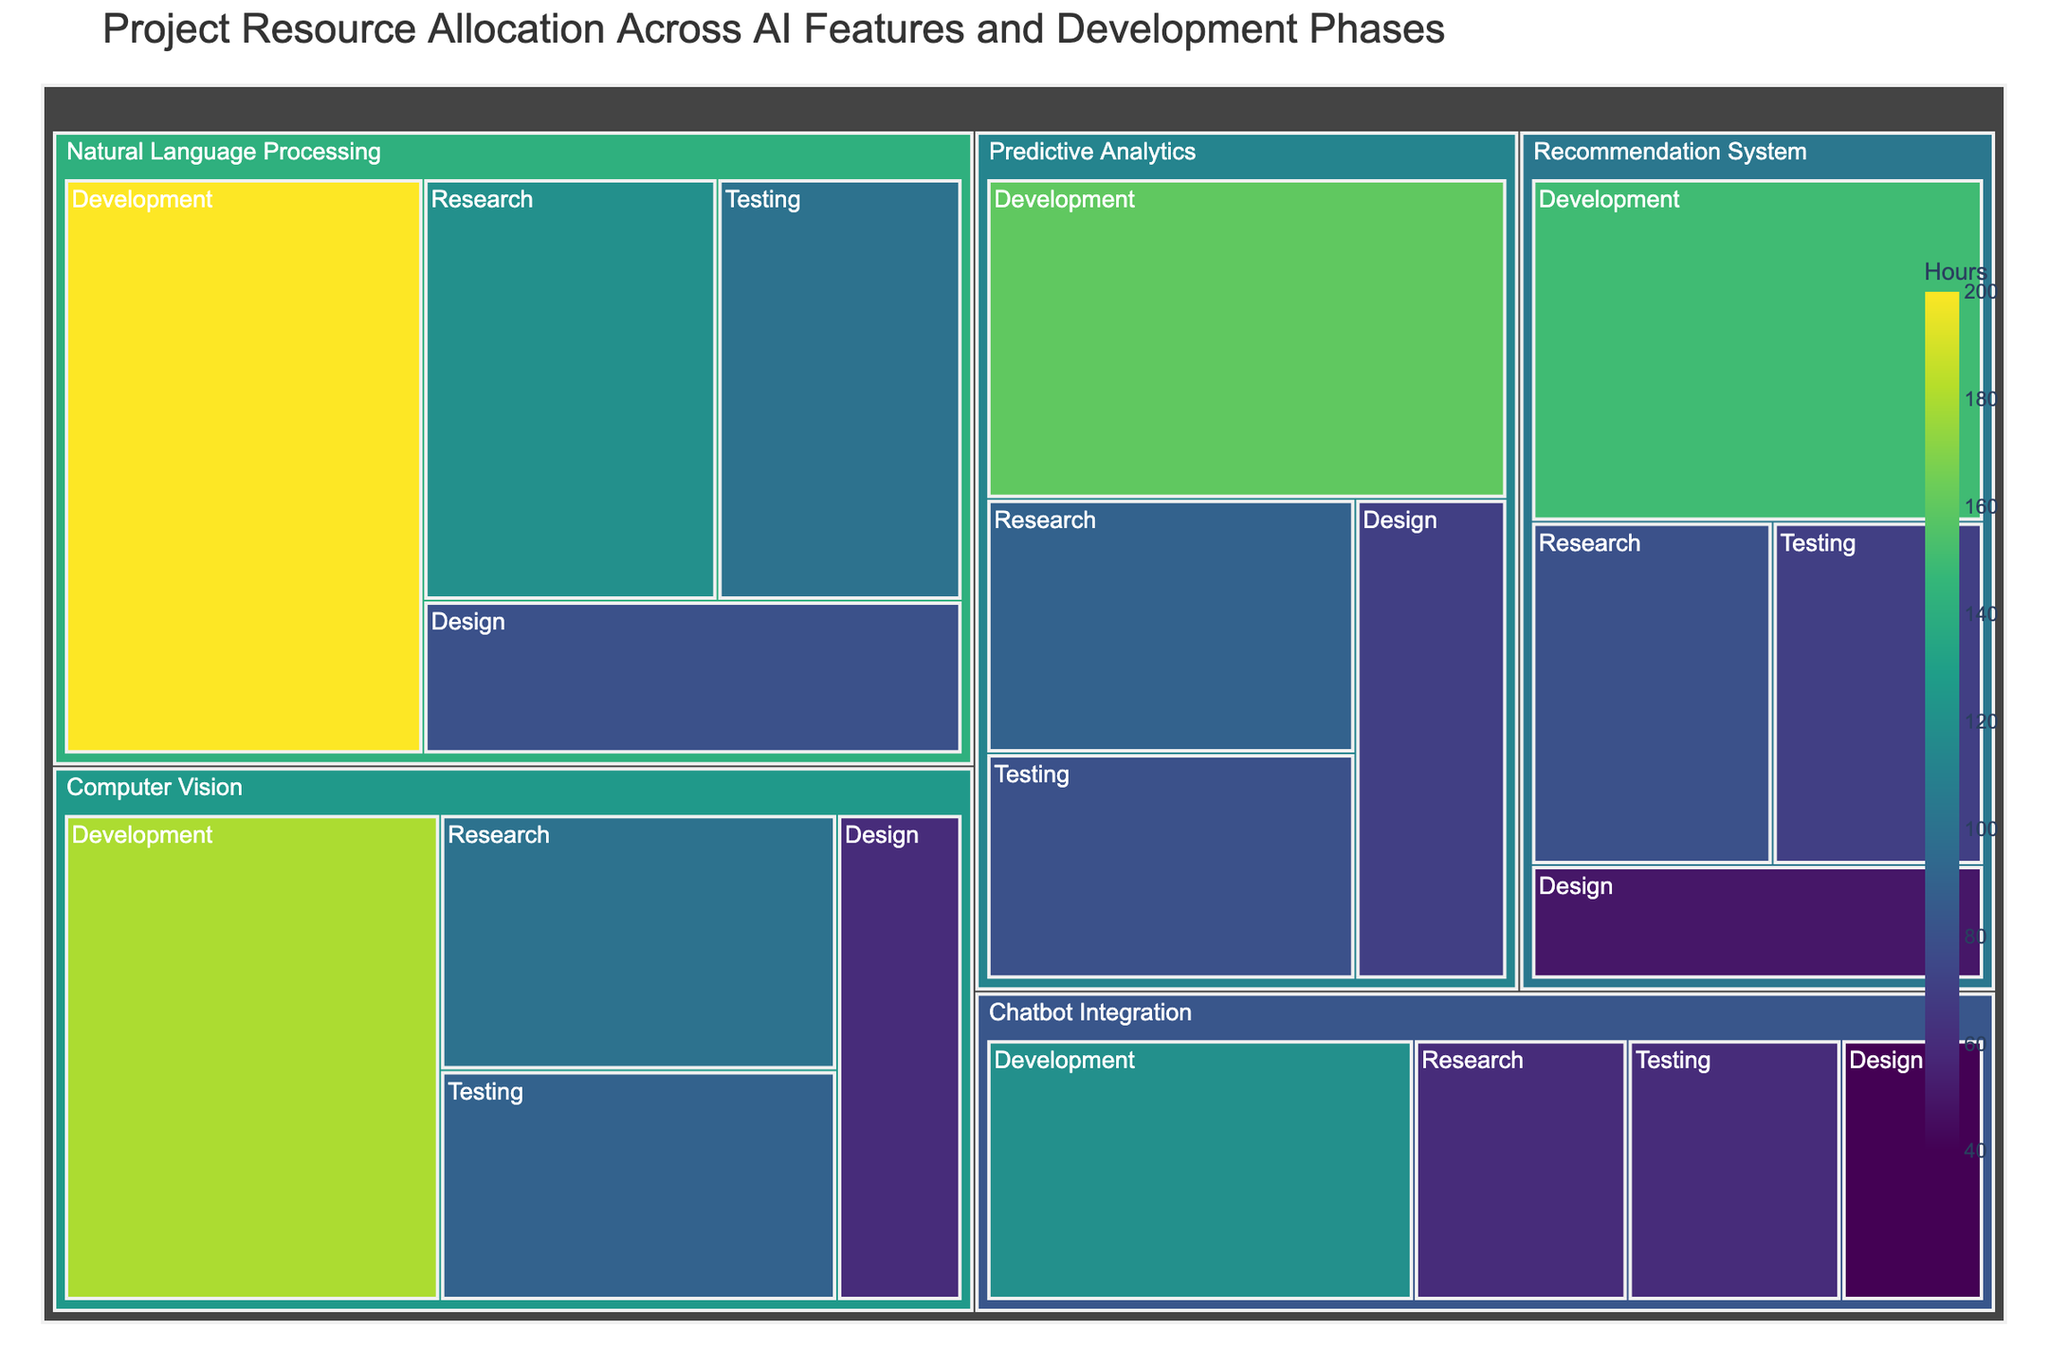What is the total number of hours allocated to the 'Computer Vision' feature? To find the total number of hours allocated to 'Computer Vision', add up the hours for all phases under this feature: Research (100), Design (60), Development (180), and Testing (90). So, 100 + 60 + 180 + 90 = 430 hours.
Answer: 430 Which phase has the highest resource allocation within the 'Natural Language Processing' feature? For 'Natural Language Processing', compare the hours across phases: Research (120), Design (80), Development (200), and Testing (100). The Development phase has the highest allocation with 200 hours.
Answer: Development How many more hours are allocated to 'Predictive Analytics' Development compared to 'Chatbot Integration' Development? Subtract the hours in 'Chatbot Integration' Development (120) from 'Predictive Analytics' Development (160). So, 160 - 120 = 40 hours.
Answer: 40 Which AI feature has the least amount of hours allocated to the Research phase? Compare the Research phase hours across all features: Natural Language Processing (120), Computer Vision (100), Recommendation System (80), Chatbot Integration (60), and Predictive Analytics (90). Chatbot Integration has the least with 60 hours.
Answer: Chatbot Integration What is the total number of hours allocated across all features and phases in the project? Sum all the hours allocated: 120 + 80 + 200 + 100 + 100 + 60 + 180 + 90 + 80 + 50 + 150 + 70 + 60 + 40 + 120 + 60 + 90 + 70 + 160 + 80. The total is 1830 hours.
Answer: 1830 Which phase has the highest overall resource allocation across all features? Sum the hours for each phase across all features: Research (450), Design (300), Development (810), and Testing (400). Development has the highest allocation with 810 hours.
Answer: Development What is the average number of hours allocated to the Testing phase for all features? To find the average, sum the hours for the Testing phase across all features (100 + 90 + 70 + 60 + 80) which equals 400, and then divide by the number of features (5). So, 400 / 5 = 80 hours.
Answer: 80 How does the resource allocation for 'Recommendation System' Development compare to the Design phase of 'Natural Language Processing'? The Development phase of 'Recommendation System' has 150 hours, and the Design phase of 'Natural Language Processing' has 80 hours. 150 is greater than 80.
Answer: Greater Which phase has the most hours allocated in the 'Chatbot Integration' feature? For 'Chatbot Integration', compare the hours across phases: Research (60), Design (40), Development (120), and Testing (60). Development has the most with 120 hours.
Answer: Development 